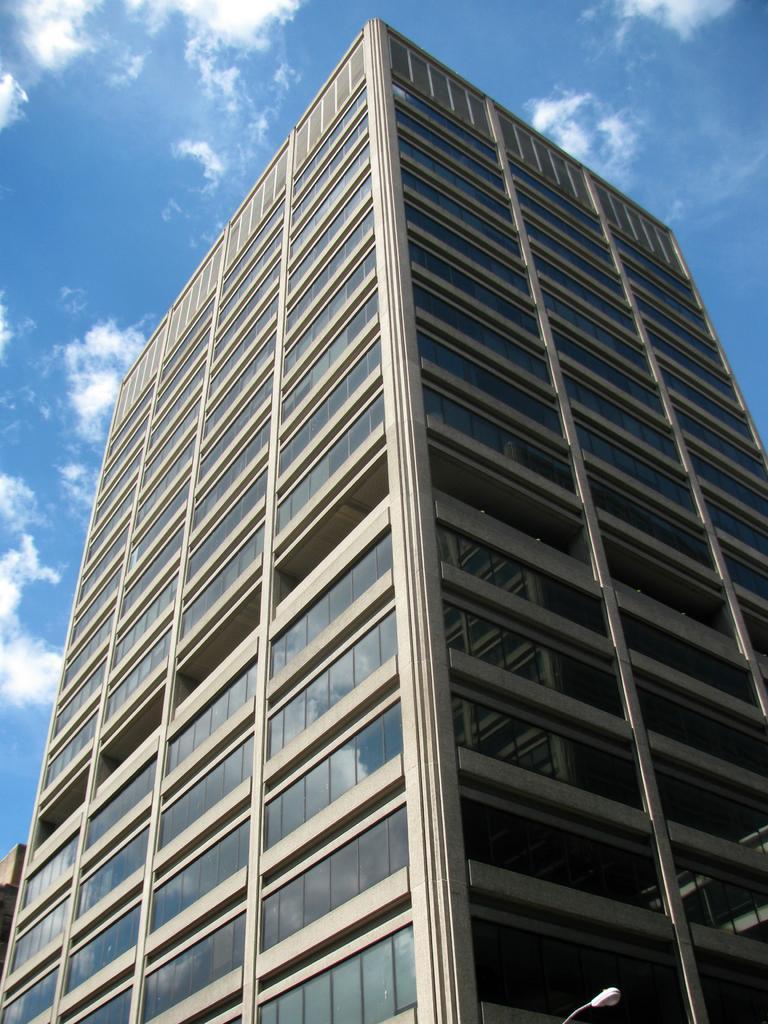Describe this image in one or two sentences. This image is taken outdoors. At the top of the image there is the sky with clouds. In the middle of the image there is a skyscraper. 